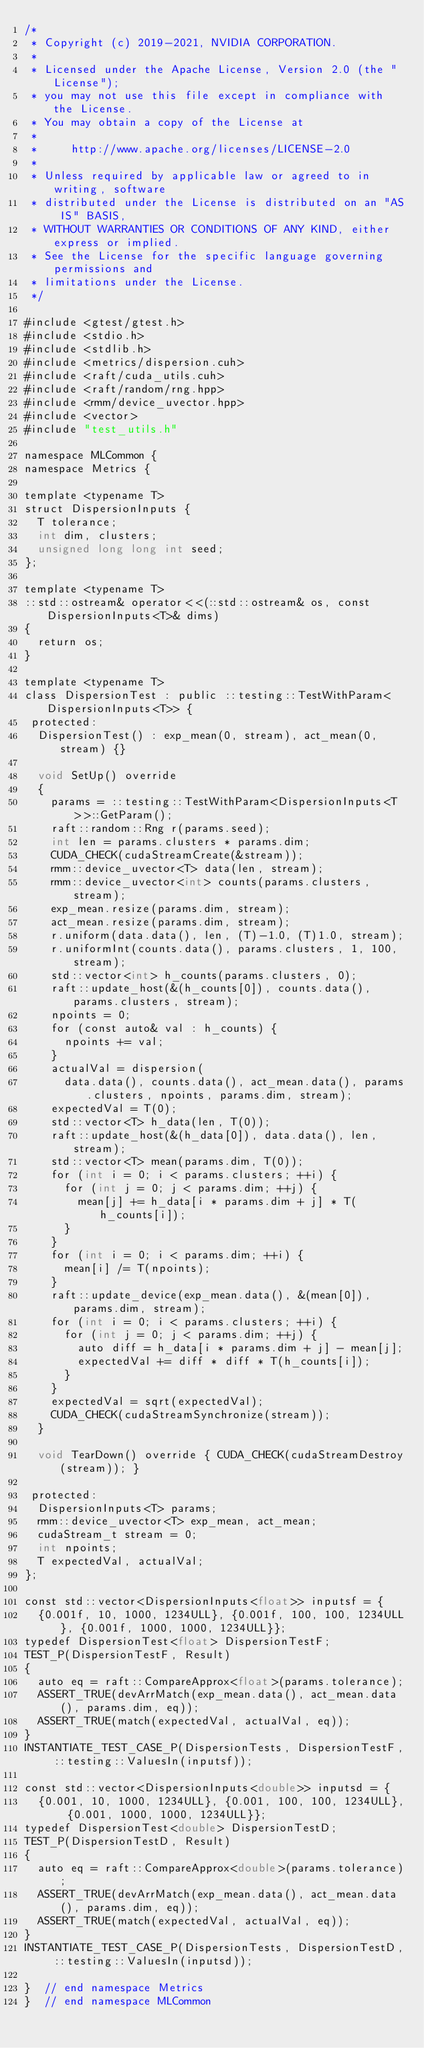<code> <loc_0><loc_0><loc_500><loc_500><_Cuda_>/*
 * Copyright (c) 2019-2021, NVIDIA CORPORATION.
 *
 * Licensed under the Apache License, Version 2.0 (the "License");
 * you may not use this file except in compliance with the License.
 * You may obtain a copy of the License at
 *
 *     http://www.apache.org/licenses/LICENSE-2.0
 *
 * Unless required by applicable law or agreed to in writing, software
 * distributed under the License is distributed on an "AS IS" BASIS,
 * WITHOUT WARRANTIES OR CONDITIONS OF ANY KIND, either express or implied.
 * See the License for the specific language governing permissions and
 * limitations under the License.
 */

#include <gtest/gtest.h>
#include <stdio.h>
#include <stdlib.h>
#include <metrics/dispersion.cuh>
#include <raft/cuda_utils.cuh>
#include <raft/random/rng.hpp>
#include <rmm/device_uvector.hpp>
#include <vector>
#include "test_utils.h"

namespace MLCommon {
namespace Metrics {

template <typename T>
struct DispersionInputs {
  T tolerance;
  int dim, clusters;
  unsigned long long int seed;
};

template <typename T>
::std::ostream& operator<<(::std::ostream& os, const DispersionInputs<T>& dims)
{
  return os;
}

template <typename T>
class DispersionTest : public ::testing::TestWithParam<DispersionInputs<T>> {
 protected:
  DispersionTest() : exp_mean(0, stream), act_mean(0, stream) {}

  void SetUp() override
  {
    params = ::testing::TestWithParam<DispersionInputs<T>>::GetParam();
    raft::random::Rng r(params.seed);
    int len = params.clusters * params.dim;
    CUDA_CHECK(cudaStreamCreate(&stream));
    rmm::device_uvector<T> data(len, stream);
    rmm::device_uvector<int> counts(params.clusters, stream);
    exp_mean.resize(params.dim, stream);
    act_mean.resize(params.dim, stream);
    r.uniform(data.data(), len, (T)-1.0, (T)1.0, stream);
    r.uniformInt(counts.data(), params.clusters, 1, 100, stream);
    std::vector<int> h_counts(params.clusters, 0);
    raft::update_host(&(h_counts[0]), counts.data(), params.clusters, stream);
    npoints = 0;
    for (const auto& val : h_counts) {
      npoints += val;
    }
    actualVal = dispersion(
      data.data(), counts.data(), act_mean.data(), params.clusters, npoints, params.dim, stream);
    expectedVal = T(0);
    std::vector<T> h_data(len, T(0));
    raft::update_host(&(h_data[0]), data.data(), len, stream);
    std::vector<T> mean(params.dim, T(0));
    for (int i = 0; i < params.clusters; ++i) {
      for (int j = 0; j < params.dim; ++j) {
        mean[j] += h_data[i * params.dim + j] * T(h_counts[i]);
      }
    }
    for (int i = 0; i < params.dim; ++i) {
      mean[i] /= T(npoints);
    }
    raft::update_device(exp_mean.data(), &(mean[0]), params.dim, stream);
    for (int i = 0; i < params.clusters; ++i) {
      for (int j = 0; j < params.dim; ++j) {
        auto diff = h_data[i * params.dim + j] - mean[j];
        expectedVal += diff * diff * T(h_counts[i]);
      }
    }
    expectedVal = sqrt(expectedVal);
    CUDA_CHECK(cudaStreamSynchronize(stream));
  }

  void TearDown() override { CUDA_CHECK(cudaStreamDestroy(stream)); }

 protected:
  DispersionInputs<T> params;
  rmm::device_uvector<T> exp_mean, act_mean;
  cudaStream_t stream = 0;
  int npoints;
  T expectedVal, actualVal;
};

const std::vector<DispersionInputs<float>> inputsf = {
  {0.001f, 10, 1000, 1234ULL}, {0.001f, 100, 100, 1234ULL}, {0.001f, 1000, 1000, 1234ULL}};
typedef DispersionTest<float> DispersionTestF;
TEST_P(DispersionTestF, Result)
{
  auto eq = raft::CompareApprox<float>(params.tolerance);
  ASSERT_TRUE(devArrMatch(exp_mean.data(), act_mean.data(), params.dim, eq));
  ASSERT_TRUE(match(expectedVal, actualVal, eq));
}
INSTANTIATE_TEST_CASE_P(DispersionTests, DispersionTestF, ::testing::ValuesIn(inputsf));

const std::vector<DispersionInputs<double>> inputsd = {
  {0.001, 10, 1000, 1234ULL}, {0.001, 100, 100, 1234ULL}, {0.001, 1000, 1000, 1234ULL}};
typedef DispersionTest<double> DispersionTestD;
TEST_P(DispersionTestD, Result)
{
  auto eq = raft::CompareApprox<double>(params.tolerance);
  ASSERT_TRUE(devArrMatch(exp_mean.data(), act_mean.data(), params.dim, eq));
  ASSERT_TRUE(match(expectedVal, actualVal, eq));
}
INSTANTIATE_TEST_CASE_P(DispersionTests, DispersionTestD, ::testing::ValuesIn(inputsd));

}  // end namespace Metrics
}  // end namespace MLCommon
</code> 